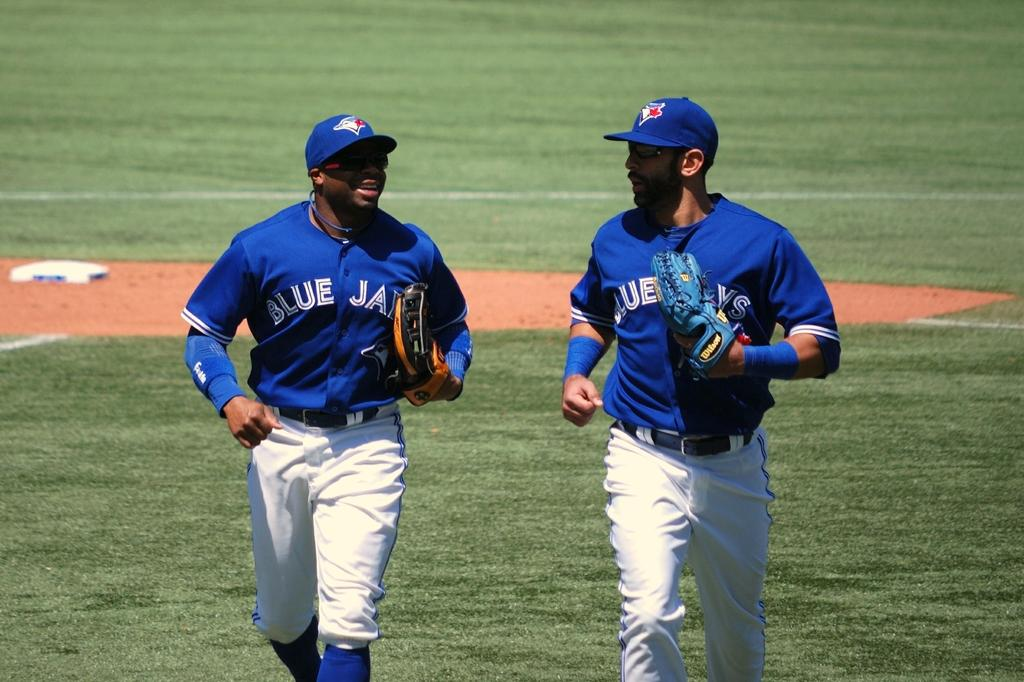Provide a one-sentence caption for the provided image. Two Blue Jays players walking on the field. 